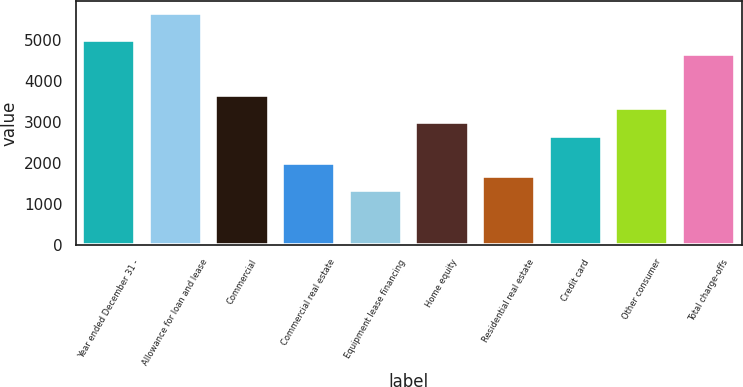Convert chart. <chart><loc_0><loc_0><loc_500><loc_500><bar_chart><fcel>Year ended December 31 -<fcel>Allowance for loan and lease<fcel>Commercial<fcel>Commercial real estate<fcel>Equipment lease financing<fcel>Home equity<fcel>Residential real estate<fcel>Credit card<fcel>Other consumer<fcel>Total charge-offs<nl><fcel>4996.39<fcel>5662.55<fcel>3664.07<fcel>1998.67<fcel>1332.51<fcel>2997.91<fcel>1665.59<fcel>2664.83<fcel>3330.99<fcel>4663.31<nl></chart> 